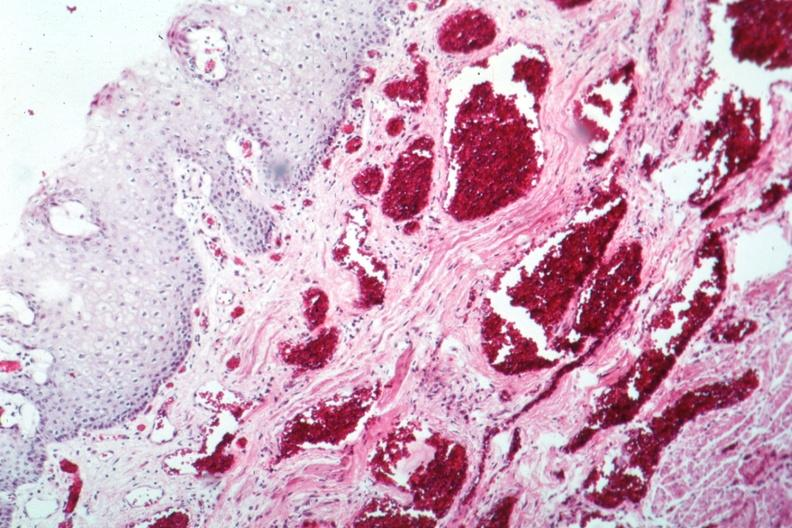what is present?
Answer the question using a single word or phrase. Esophagus 